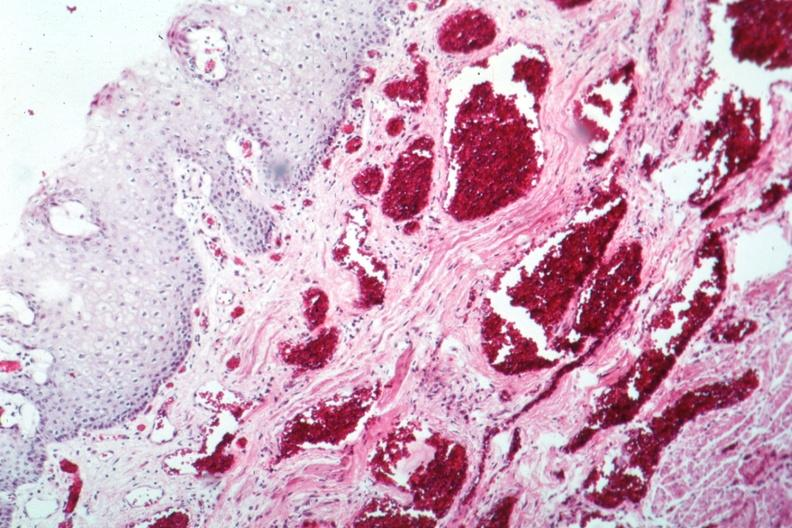what is present?
Answer the question using a single word or phrase. Esophagus 